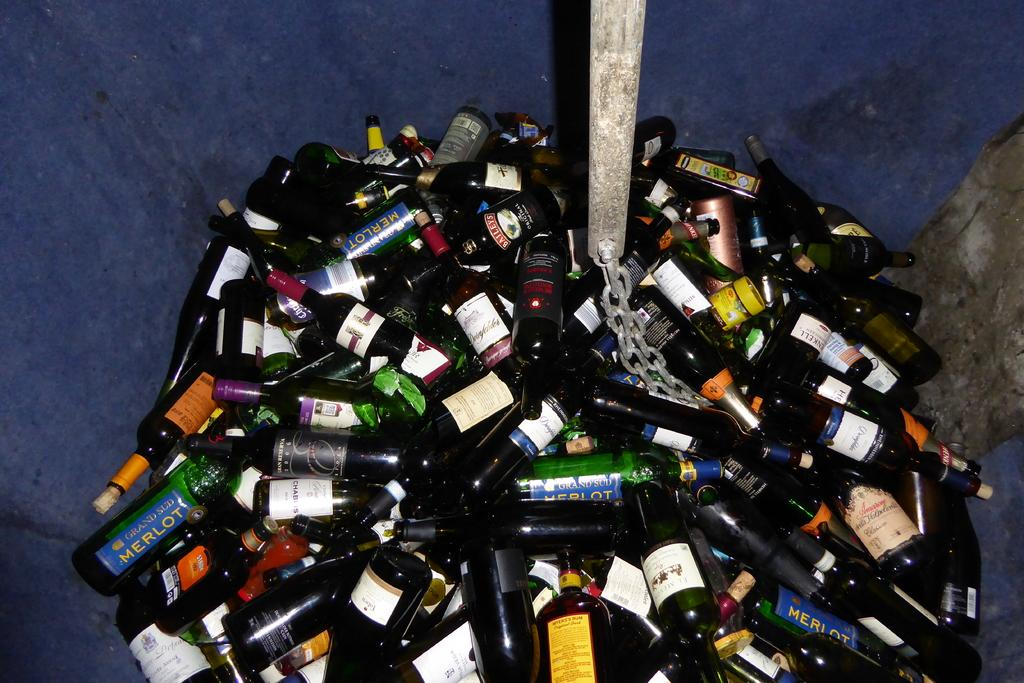<image>
Create a compact narrative representing the image presented. a trash bin filled with empty bottles of merlot 